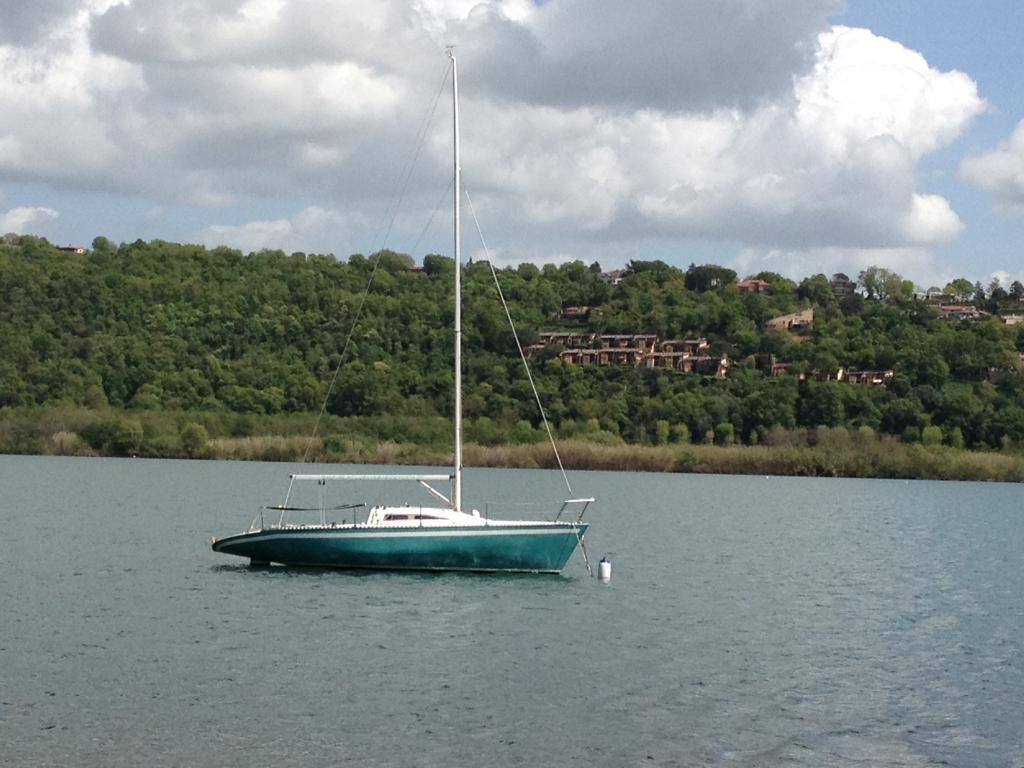What is the main feature of the image? The main feature of the image is water. What is located on the water? There is a ship on the water. What type of vegetation can be seen in the image? There are green trees in the image. What type of structures are present in the image? There are homes in the image. What is visible at the top of the image? The sky is visible at the top of the image, and there are clouds in the sky. What type of writing can be seen on the ship? There is no writing visible on the ship in the image. 